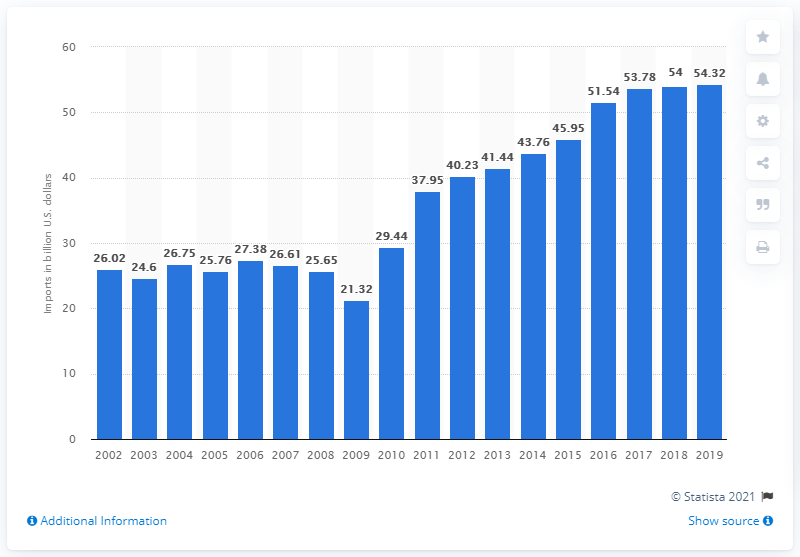Outline some significant characteristics in this image. In 2019, the total value of U.S. imports of semiconductors and related devices was $54.32 billion. 